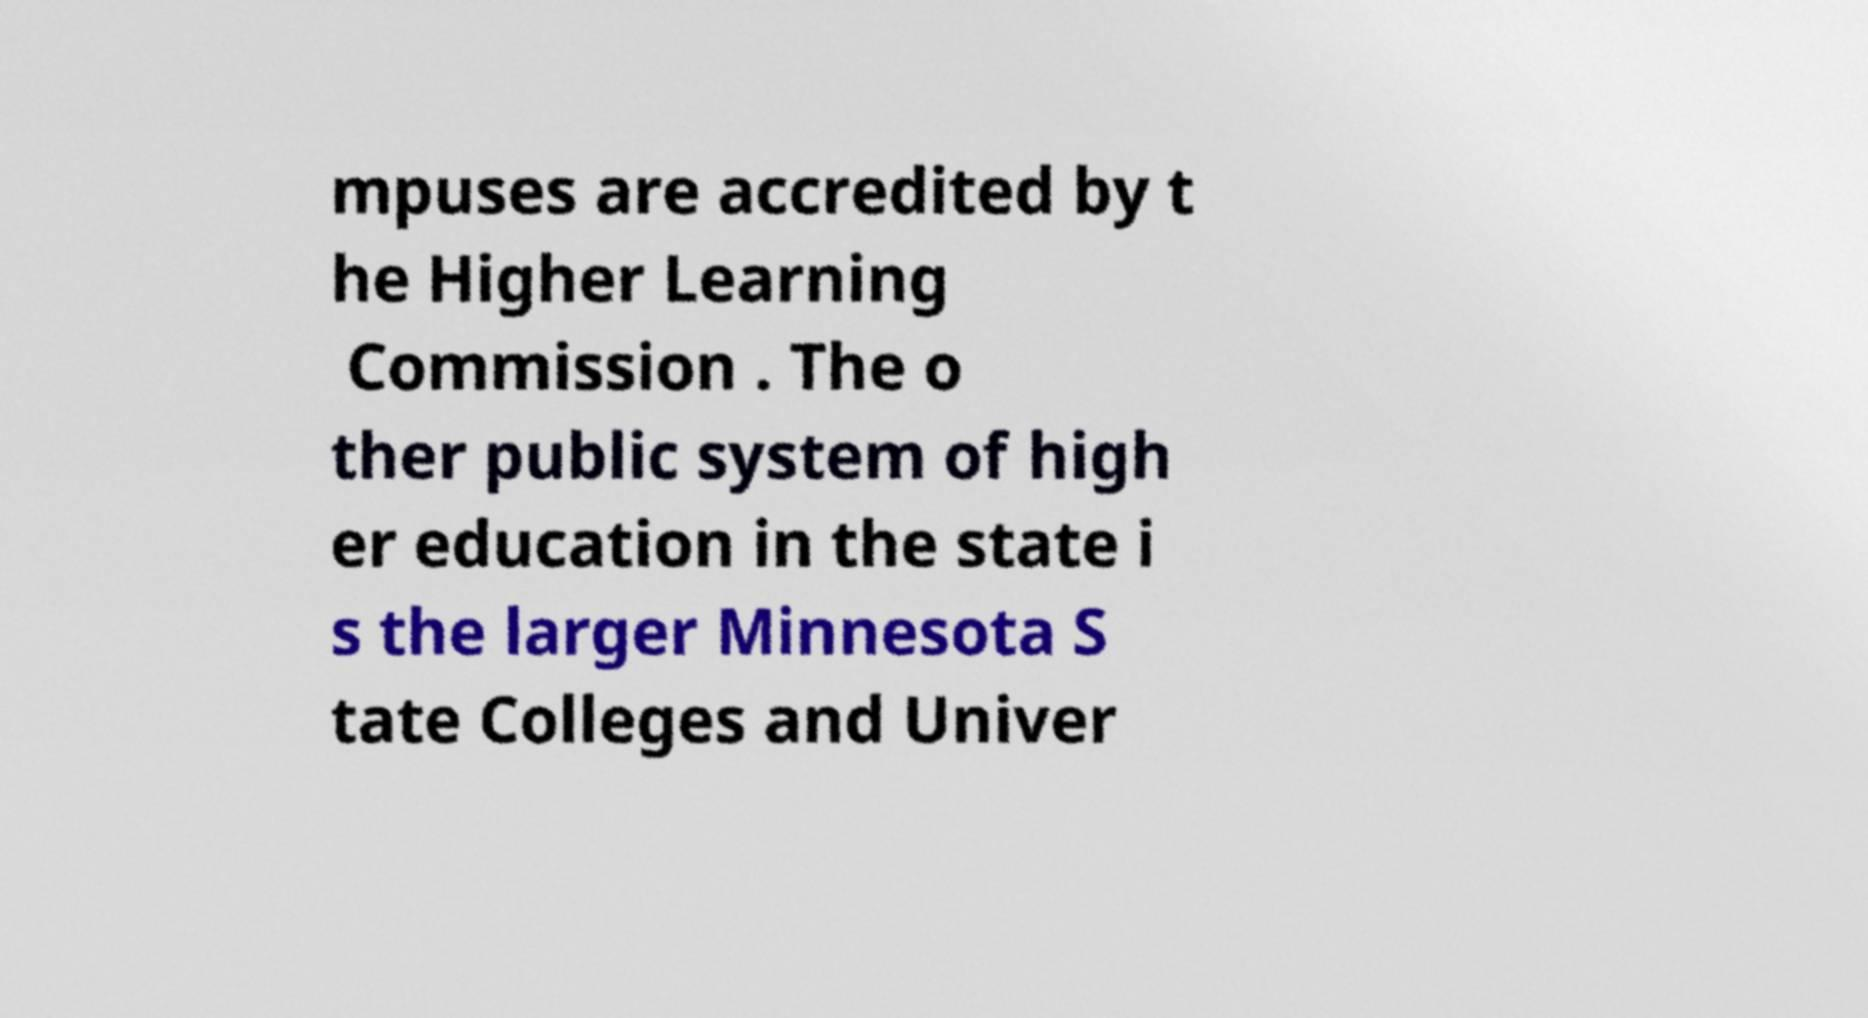For documentation purposes, I need the text within this image transcribed. Could you provide that? mpuses are accredited by t he Higher Learning Commission . The o ther public system of high er education in the state i s the larger Minnesota S tate Colleges and Univer 